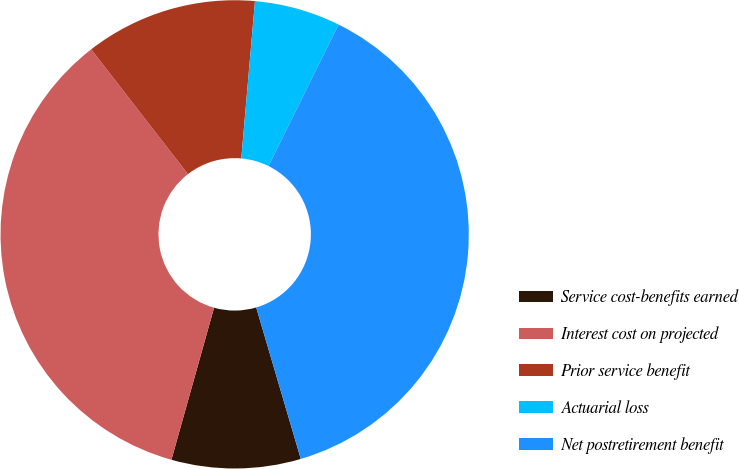Convert chart to OTSL. <chart><loc_0><loc_0><loc_500><loc_500><pie_chart><fcel>Service cost-benefits earned<fcel>Interest cost on projected<fcel>Prior service benefit<fcel>Actuarial loss<fcel>Net postretirement benefit<nl><fcel>8.91%<fcel>35.15%<fcel>11.88%<fcel>5.94%<fcel>38.12%<nl></chart> 